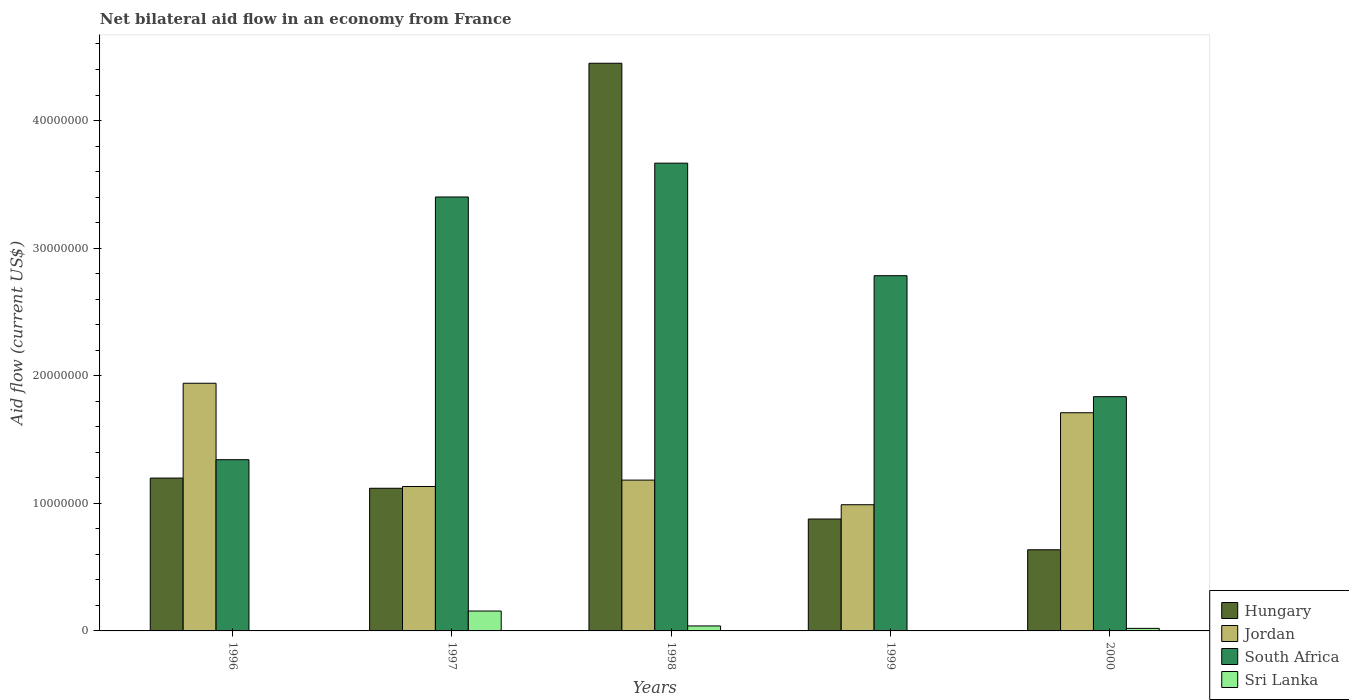How many groups of bars are there?
Your response must be concise. 5. Are the number of bars on each tick of the X-axis equal?
Your answer should be very brief. No. How many bars are there on the 3rd tick from the right?
Give a very brief answer. 4. What is the label of the 4th group of bars from the left?
Ensure brevity in your answer.  1999. In how many cases, is the number of bars for a given year not equal to the number of legend labels?
Provide a short and direct response. 2. What is the net bilateral aid flow in Sri Lanka in 1999?
Offer a terse response. 0. Across all years, what is the maximum net bilateral aid flow in Sri Lanka?
Provide a short and direct response. 1.56e+06. Across all years, what is the minimum net bilateral aid flow in Hungary?
Your answer should be very brief. 6.36e+06. What is the total net bilateral aid flow in Hungary in the graph?
Offer a terse response. 8.28e+07. What is the difference between the net bilateral aid flow in Jordan in 1996 and that in 1999?
Your answer should be compact. 9.52e+06. What is the difference between the net bilateral aid flow in Sri Lanka in 1997 and the net bilateral aid flow in South Africa in 1999?
Your response must be concise. -2.63e+07. What is the average net bilateral aid flow in Hungary per year?
Ensure brevity in your answer.  1.66e+07. In the year 1998, what is the difference between the net bilateral aid flow in Sri Lanka and net bilateral aid flow in Hungary?
Provide a succinct answer. -4.41e+07. What is the ratio of the net bilateral aid flow in Hungary in 1997 to that in 2000?
Keep it short and to the point. 1.76. Is the net bilateral aid flow in Sri Lanka in 1997 less than that in 2000?
Give a very brief answer. No. Is the difference between the net bilateral aid flow in Sri Lanka in 1997 and 2000 greater than the difference between the net bilateral aid flow in Hungary in 1997 and 2000?
Offer a terse response. No. What is the difference between the highest and the second highest net bilateral aid flow in Sri Lanka?
Your answer should be very brief. 1.17e+06. What is the difference between the highest and the lowest net bilateral aid flow in Hungary?
Provide a short and direct response. 3.81e+07. Is the sum of the net bilateral aid flow in Jordan in 1998 and 2000 greater than the maximum net bilateral aid flow in South Africa across all years?
Your response must be concise. No. Is it the case that in every year, the sum of the net bilateral aid flow in Sri Lanka and net bilateral aid flow in South Africa is greater than the net bilateral aid flow in Jordan?
Make the answer very short. No. How many bars are there?
Your answer should be compact. 18. Where does the legend appear in the graph?
Your response must be concise. Bottom right. How many legend labels are there?
Provide a succinct answer. 4. What is the title of the graph?
Offer a very short reply. Net bilateral aid flow in an economy from France. Does "Qatar" appear as one of the legend labels in the graph?
Provide a succinct answer. No. What is the label or title of the Y-axis?
Ensure brevity in your answer.  Aid flow (current US$). What is the Aid flow (current US$) of Hungary in 1996?
Keep it short and to the point. 1.20e+07. What is the Aid flow (current US$) of Jordan in 1996?
Provide a succinct answer. 1.94e+07. What is the Aid flow (current US$) of South Africa in 1996?
Ensure brevity in your answer.  1.34e+07. What is the Aid flow (current US$) in Hungary in 1997?
Your answer should be very brief. 1.12e+07. What is the Aid flow (current US$) of Jordan in 1997?
Keep it short and to the point. 1.13e+07. What is the Aid flow (current US$) in South Africa in 1997?
Offer a very short reply. 3.40e+07. What is the Aid flow (current US$) of Sri Lanka in 1997?
Ensure brevity in your answer.  1.56e+06. What is the Aid flow (current US$) of Hungary in 1998?
Give a very brief answer. 4.45e+07. What is the Aid flow (current US$) in Jordan in 1998?
Give a very brief answer. 1.18e+07. What is the Aid flow (current US$) in South Africa in 1998?
Make the answer very short. 3.67e+07. What is the Aid flow (current US$) of Sri Lanka in 1998?
Your answer should be compact. 3.90e+05. What is the Aid flow (current US$) in Hungary in 1999?
Your response must be concise. 8.77e+06. What is the Aid flow (current US$) of Jordan in 1999?
Your answer should be compact. 9.89e+06. What is the Aid flow (current US$) in South Africa in 1999?
Provide a short and direct response. 2.78e+07. What is the Aid flow (current US$) of Hungary in 2000?
Your answer should be very brief. 6.36e+06. What is the Aid flow (current US$) in Jordan in 2000?
Make the answer very short. 1.71e+07. What is the Aid flow (current US$) of South Africa in 2000?
Provide a short and direct response. 1.84e+07. Across all years, what is the maximum Aid flow (current US$) of Hungary?
Your answer should be compact. 4.45e+07. Across all years, what is the maximum Aid flow (current US$) in Jordan?
Provide a succinct answer. 1.94e+07. Across all years, what is the maximum Aid flow (current US$) in South Africa?
Your answer should be very brief. 3.67e+07. Across all years, what is the maximum Aid flow (current US$) in Sri Lanka?
Your response must be concise. 1.56e+06. Across all years, what is the minimum Aid flow (current US$) in Hungary?
Keep it short and to the point. 6.36e+06. Across all years, what is the minimum Aid flow (current US$) in Jordan?
Provide a succinct answer. 9.89e+06. Across all years, what is the minimum Aid flow (current US$) of South Africa?
Ensure brevity in your answer.  1.34e+07. Across all years, what is the minimum Aid flow (current US$) of Sri Lanka?
Provide a succinct answer. 0. What is the total Aid flow (current US$) in Hungary in the graph?
Keep it short and to the point. 8.28e+07. What is the total Aid flow (current US$) of Jordan in the graph?
Ensure brevity in your answer.  6.95e+07. What is the total Aid flow (current US$) in South Africa in the graph?
Keep it short and to the point. 1.30e+08. What is the total Aid flow (current US$) in Sri Lanka in the graph?
Offer a very short reply. 2.15e+06. What is the difference between the Aid flow (current US$) in Jordan in 1996 and that in 1997?
Give a very brief answer. 8.09e+06. What is the difference between the Aid flow (current US$) of South Africa in 1996 and that in 1997?
Ensure brevity in your answer.  -2.06e+07. What is the difference between the Aid flow (current US$) in Hungary in 1996 and that in 1998?
Offer a terse response. -3.25e+07. What is the difference between the Aid flow (current US$) in Jordan in 1996 and that in 1998?
Provide a short and direct response. 7.59e+06. What is the difference between the Aid flow (current US$) of South Africa in 1996 and that in 1998?
Ensure brevity in your answer.  -2.32e+07. What is the difference between the Aid flow (current US$) in Hungary in 1996 and that in 1999?
Ensure brevity in your answer.  3.21e+06. What is the difference between the Aid flow (current US$) in Jordan in 1996 and that in 1999?
Your answer should be very brief. 9.52e+06. What is the difference between the Aid flow (current US$) of South Africa in 1996 and that in 1999?
Your answer should be very brief. -1.44e+07. What is the difference between the Aid flow (current US$) in Hungary in 1996 and that in 2000?
Ensure brevity in your answer.  5.62e+06. What is the difference between the Aid flow (current US$) of Jordan in 1996 and that in 2000?
Your answer should be very brief. 2.31e+06. What is the difference between the Aid flow (current US$) of South Africa in 1996 and that in 2000?
Make the answer very short. -4.94e+06. What is the difference between the Aid flow (current US$) of Hungary in 1997 and that in 1998?
Give a very brief answer. -3.33e+07. What is the difference between the Aid flow (current US$) in Jordan in 1997 and that in 1998?
Your response must be concise. -5.00e+05. What is the difference between the Aid flow (current US$) in South Africa in 1997 and that in 1998?
Ensure brevity in your answer.  -2.65e+06. What is the difference between the Aid flow (current US$) of Sri Lanka in 1997 and that in 1998?
Your response must be concise. 1.17e+06. What is the difference between the Aid flow (current US$) of Hungary in 1997 and that in 1999?
Your answer should be compact. 2.41e+06. What is the difference between the Aid flow (current US$) in Jordan in 1997 and that in 1999?
Give a very brief answer. 1.43e+06. What is the difference between the Aid flow (current US$) in South Africa in 1997 and that in 1999?
Keep it short and to the point. 6.17e+06. What is the difference between the Aid flow (current US$) in Hungary in 1997 and that in 2000?
Give a very brief answer. 4.82e+06. What is the difference between the Aid flow (current US$) of Jordan in 1997 and that in 2000?
Provide a succinct answer. -5.78e+06. What is the difference between the Aid flow (current US$) of South Africa in 1997 and that in 2000?
Offer a terse response. 1.56e+07. What is the difference between the Aid flow (current US$) of Sri Lanka in 1997 and that in 2000?
Offer a very short reply. 1.36e+06. What is the difference between the Aid flow (current US$) in Hungary in 1998 and that in 1999?
Give a very brief answer. 3.57e+07. What is the difference between the Aid flow (current US$) in Jordan in 1998 and that in 1999?
Your answer should be compact. 1.93e+06. What is the difference between the Aid flow (current US$) of South Africa in 1998 and that in 1999?
Provide a short and direct response. 8.82e+06. What is the difference between the Aid flow (current US$) in Hungary in 1998 and that in 2000?
Your response must be concise. 3.81e+07. What is the difference between the Aid flow (current US$) in Jordan in 1998 and that in 2000?
Provide a succinct answer. -5.28e+06. What is the difference between the Aid flow (current US$) in South Africa in 1998 and that in 2000?
Offer a terse response. 1.83e+07. What is the difference between the Aid flow (current US$) of Hungary in 1999 and that in 2000?
Ensure brevity in your answer.  2.41e+06. What is the difference between the Aid flow (current US$) of Jordan in 1999 and that in 2000?
Keep it short and to the point. -7.21e+06. What is the difference between the Aid flow (current US$) of South Africa in 1999 and that in 2000?
Your answer should be very brief. 9.48e+06. What is the difference between the Aid flow (current US$) in Hungary in 1996 and the Aid flow (current US$) in Jordan in 1997?
Make the answer very short. 6.60e+05. What is the difference between the Aid flow (current US$) of Hungary in 1996 and the Aid flow (current US$) of South Africa in 1997?
Your answer should be compact. -2.20e+07. What is the difference between the Aid flow (current US$) of Hungary in 1996 and the Aid flow (current US$) of Sri Lanka in 1997?
Offer a terse response. 1.04e+07. What is the difference between the Aid flow (current US$) of Jordan in 1996 and the Aid flow (current US$) of South Africa in 1997?
Provide a short and direct response. -1.46e+07. What is the difference between the Aid flow (current US$) in Jordan in 1996 and the Aid flow (current US$) in Sri Lanka in 1997?
Keep it short and to the point. 1.78e+07. What is the difference between the Aid flow (current US$) of South Africa in 1996 and the Aid flow (current US$) of Sri Lanka in 1997?
Offer a terse response. 1.19e+07. What is the difference between the Aid flow (current US$) of Hungary in 1996 and the Aid flow (current US$) of South Africa in 1998?
Your answer should be very brief. -2.47e+07. What is the difference between the Aid flow (current US$) in Hungary in 1996 and the Aid flow (current US$) in Sri Lanka in 1998?
Your answer should be very brief. 1.16e+07. What is the difference between the Aid flow (current US$) of Jordan in 1996 and the Aid flow (current US$) of South Africa in 1998?
Your answer should be very brief. -1.72e+07. What is the difference between the Aid flow (current US$) of Jordan in 1996 and the Aid flow (current US$) of Sri Lanka in 1998?
Your answer should be compact. 1.90e+07. What is the difference between the Aid flow (current US$) in South Africa in 1996 and the Aid flow (current US$) in Sri Lanka in 1998?
Provide a short and direct response. 1.30e+07. What is the difference between the Aid flow (current US$) in Hungary in 1996 and the Aid flow (current US$) in Jordan in 1999?
Make the answer very short. 2.09e+06. What is the difference between the Aid flow (current US$) of Hungary in 1996 and the Aid flow (current US$) of South Africa in 1999?
Offer a terse response. -1.59e+07. What is the difference between the Aid flow (current US$) of Jordan in 1996 and the Aid flow (current US$) of South Africa in 1999?
Make the answer very short. -8.43e+06. What is the difference between the Aid flow (current US$) in Hungary in 1996 and the Aid flow (current US$) in Jordan in 2000?
Keep it short and to the point. -5.12e+06. What is the difference between the Aid flow (current US$) of Hungary in 1996 and the Aid flow (current US$) of South Africa in 2000?
Keep it short and to the point. -6.38e+06. What is the difference between the Aid flow (current US$) in Hungary in 1996 and the Aid flow (current US$) in Sri Lanka in 2000?
Give a very brief answer. 1.18e+07. What is the difference between the Aid flow (current US$) of Jordan in 1996 and the Aid flow (current US$) of South Africa in 2000?
Make the answer very short. 1.05e+06. What is the difference between the Aid flow (current US$) of Jordan in 1996 and the Aid flow (current US$) of Sri Lanka in 2000?
Ensure brevity in your answer.  1.92e+07. What is the difference between the Aid flow (current US$) of South Africa in 1996 and the Aid flow (current US$) of Sri Lanka in 2000?
Offer a terse response. 1.32e+07. What is the difference between the Aid flow (current US$) of Hungary in 1997 and the Aid flow (current US$) of Jordan in 1998?
Your response must be concise. -6.40e+05. What is the difference between the Aid flow (current US$) of Hungary in 1997 and the Aid flow (current US$) of South Africa in 1998?
Ensure brevity in your answer.  -2.55e+07. What is the difference between the Aid flow (current US$) of Hungary in 1997 and the Aid flow (current US$) of Sri Lanka in 1998?
Your answer should be compact. 1.08e+07. What is the difference between the Aid flow (current US$) in Jordan in 1997 and the Aid flow (current US$) in South Africa in 1998?
Your answer should be compact. -2.53e+07. What is the difference between the Aid flow (current US$) in Jordan in 1997 and the Aid flow (current US$) in Sri Lanka in 1998?
Your answer should be very brief. 1.09e+07. What is the difference between the Aid flow (current US$) in South Africa in 1997 and the Aid flow (current US$) in Sri Lanka in 1998?
Offer a terse response. 3.36e+07. What is the difference between the Aid flow (current US$) of Hungary in 1997 and the Aid flow (current US$) of Jordan in 1999?
Ensure brevity in your answer.  1.29e+06. What is the difference between the Aid flow (current US$) of Hungary in 1997 and the Aid flow (current US$) of South Africa in 1999?
Your response must be concise. -1.67e+07. What is the difference between the Aid flow (current US$) in Jordan in 1997 and the Aid flow (current US$) in South Africa in 1999?
Give a very brief answer. -1.65e+07. What is the difference between the Aid flow (current US$) in Hungary in 1997 and the Aid flow (current US$) in Jordan in 2000?
Give a very brief answer. -5.92e+06. What is the difference between the Aid flow (current US$) of Hungary in 1997 and the Aid flow (current US$) of South Africa in 2000?
Provide a succinct answer. -7.18e+06. What is the difference between the Aid flow (current US$) of Hungary in 1997 and the Aid flow (current US$) of Sri Lanka in 2000?
Give a very brief answer. 1.10e+07. What is the difference between the Aid flow (current US$) of Jordan in 1997 and the Aid flow (current US$) of South Africa in 2000?
Give a very brief answer. -7.04e+06. What is the difference between the Aid flow (current US$) of Jordan in 1997 and the Aid flow (current US$) of Sri Lanka in 2000?
Your answer should be very brief. 1.11e+07. What is the difference between the Aid flow (current US$) in South Africa in 1997 and the Aid flow (current US$) in Sri Lanka in 2000?
Offer a terse response. 3.38e+07. What is the difference between the Aid flow (current US$) in Hungary in 1998 and the Aid flow (current US$) in Jordan in 1999?
Your response must be concise. 3.46e+07. What is the difference between the Aid flow (current US$) of Hungary in 1998 and the Aid flow (current US$) of South Africa in 1999?
Offer a very short reply. 1.66e+07. What is the difference between the Aid flow (current US$) of Jordan in 1998 and the Aid flow (current US$) of South Africa in 1999?
Offer a terse response. -1.60e+07. What is the difference between the Aid flow (current US$) in Hungary in 1998 and the Aid flow (current US$) in Jordan in 2000?
Keep it short and to the point. 2.74e+07. What is the difference between the Aid flow (current US$) in Hungary in 1998 and the Aid flow (current US$) in South Africa in 2000?
Provide a short and direct response. 2.61e+07. What is the difference between the Aid flow (current US$) in Hungary in 1998 and the Aid flow (current US$) in Sri Lanka in 2000?
Your response must be concise. 4.43e+07. What is the difference between the Aid flow (current US$) in Jordan in 1998 and the Aid flow (current US$) in South Africa in 2000?
Your answer should be very brief. -6.54e+06. What is the difference between the Aid flow (current US$) of Jordan in 1998 and the Aid flow (current US$) of Sri Lanka in 2000?
Your response must be concise. 1.16e+07. What is the difference between the Aid flow (current US$) in South Africa in 1998 and the Aid flow (current US$) in Sri Lanka in 2000?
Offer a terse response. 3.65e+07. What is the difference between the Aid flow (current US$) in Hungary in 1999 and the Aid flow (current US$) in Jordan in 2000?
Keep it short and to the point. -8.33e+06. What is the difference between the Aid flow (current US$) of Hungary in 1999 and the Aid flow (current US$) of South Africa in 2000?
Provide a short and direct response. -9.59e+06. What is the difference between the Aid flow (current US$) of Hungary in 1999 and the Aid flow (current US$) of Sri Lanka in 2000?
Offer a terse response. 8.57e+06. What is the difference between the Aid flow (current US$) in Jordan in 1999 and the Aid flow (current US$) in South Africa in 2000?
Give a very brief answer. -8.47e+06. What is the difference between the Aid flow (current US$) of Jordan in 1999 and the Aid flow (current US$) of Sri Lanka in 2000?
Provide a short and direct response. 9.69e+06. What is the difference between the Aid flow (current US$) in South Africa in 1999 and the Aid flow (current US$) in Sri Lanka in 2000?
Your answer should be compact. 2.76e+07. What is the average Aid flow (current US$) of Hungary per year?
Provide a short and direct response. 1.66e+07. What is the average Aid flow (current US$) in Jordan per year?
Your answer should be compact. 1.39e+07. What is the average Aid flow (current US$) in South Africa per year?
Offer a very short reply. 2.61e+07. What is the average Aid flow (current US$) of Sri Lanka per year?
Keep it short and to the point. 4.30e+05. In the year 1996, what is the difference between the Aid flow (current US$) in Hungary and Aid flow (current US$) in Jordan?
Offer a terse response. -7.43e+06. In the year 1996, what is the difference between the Aid flow (current US$) of Hungary and Aid flow (current US$) of South Africa?
Give a very brief answer. -1.44e+06. In the year 1996, what is the difference between the Aid flow (current US$) in Jordan and Aid flow (current US$) in South Africa?
Ensure brevity in your answer.  5.99e+06. In the year 1997, what is the difference between the Aid flow (current US$) of Hungary and Aid flow (current US$) of Jordan?
Provide a succinct answer. -1.40e+05. In the year 1997, what is the difference between the Aid flow (current US$) in Hungary and Aid flow (current US$) in South Africa?
Your answer should be compact. -2.28e+07. In the year 1997, what is the difference between the Aid flow (current US$) of Hungary and Aid flow (current US$) of Sri Lanka?
Ensure brevity in your answer.  9.62e+06. In the year 1997, what is the difference between the Aid flow (current US$) of Jordan and Aid flow (current US$) of South Africa?
Your answer should be compact. -2.27e+07. In the year 1997, what is the difference between the Aid flow (current US$) of Jordan and Aid flow (current US$) of Sri Lanka?
Your response must be concise. 9.76e+06. In the year 1997, what is the difference between the Aid flow (current US$) in South Africa and Aid flow (current US$) in Sri Lanka?
Make the answer very short. 3.24e+07. In the year 1998, what is the difference between the Aid flow (current US$) of Hungary and Aid flow (current US$) of Jordan?
Make the answer very short. 3.27e+07. In the year 1998, what is the difference between the Aid flow (current US$) in Hungary and Aid flow (current US$) in South Africa?
Your response must be concise. 7.83e+06. In the year 1998, what is the difference between the Aid flow (current US$) of Hungary and Aid flow (current US$) of Sri Lanka?
Your answer should be very brief. 4.41e+07. In the year 1998, what is the difference between the Aid flow (current US$) in Jordan and Aid flow (current US$) in South Africa?
Your answer should be compact. -2.48e+07. In the year 1998, what is the difference between the Aid flow (current US$) in Jordan and Aid flow (current US$) in Sri Lanka?
Your response must be concise. 1.14e+07. In the year 1998, what is the difference between the Aid flow (current US$) in South Africa and Aid flow (current US$) in Sri Lanka?
Your answer should be very brief. 3.63e+07. In the year 1999, what is the difference between the Aid flow (current US$) of Hungary and Aid flow (current US$) of Jordan?
Keep it short and to the point. -1.12e+06. In the year 1999, what is the difference between the Aid flow (current US$) in Hungary and Aid flow (current US$) in South Africa?
Your answer should be compact. -1.91e+07. In the year 1999, what is the difference between the Aid flow (current US$) of Jordan and Aid flow (current US$) of South Africa?
Provide a succinct answer. -1.80e+07. In the year 2000, what is the difference between the Aid flow (current US$) in Hungary and Aid flow (current US$) in Jordan?
Your response must be concise. -1.07e+07. In the year 2000, what is the difference between the Aid flow (current US$) in Hungary and Aid flow (current US$) in South Africa?
Your answer should be very brief. -1.20e+07. In the year 2000, what is the difference between the Aid flow (current US$) in Hungary and Aid flow (current US$) in Sri Lanka?
Ensure brevity in your answer.  6.16e+06. In the year 2000, what is the difference between the Aid flow (current US$) of Jordan and Aid flow (current US$) of South Africa?
Ensure brevity in your answer.  -1.26e+06. In the year 2000, what is the difference between the Aid flow (current US$) of Jordan and Aid flow (current US$) of Sri Lanka?
Keep it short and to the point. 1.69e+07. In the year 2000, what is the difference between the Aid flow (current US$) in South Africa and Aid flow (current US$) in Sri Lanka?
Keep it short and to the point. 1.82e+07. What is the ratio of the Aid flow (current US$) in Hungary in 1996 to that in 1997?
Make the answer very short. 1.07. What is the ratio of the Aid flow (current US$) in Jordan in 1996 to that in 1997?
Your answer should be compact. 1.71. What is the ratio of the Aid flow (current US$) in South Africa in 1996 to that in 1997?
Ensure brevity in your answer.  0.39. What is the ratio of the Aid flow (current US$) in Hungary in 1996 to that in 1998?
Provide a short and direct response. 0.27. What is the ratio of the Aid flow (current US$) of Jordan in 1996 to that in 1998?
Keep it short and to the point. 1.64. What is the ratio of the Aid flow (current US$) of South Africa in 1996 to that in 1998?
Give a very brief answer. 0.37. What is the ratio of the Aid flow (current US$) in Hungary in 1996 to that in 1999?
Ensure brevity in your answer.  1.37. What is the ratio of the Aid flow (current US$) in Jordan in 1996 to that in 1999?
Ensure brevity in your answer.  1.96. What is the ratio of the Aid flow (current US$) of South Africa in 1996 to that in 1999?
Offer a terse response. 0.48. What is the ratio of the Aid flow (current US$) of Hungary in 1996 to that in 2000?
Make the answer very short. 1.88. What is the ratio of the Aid flow (current US$) of Jordan in 1996 to that in 2000?
Your answer should be very brief. 1.14. What is the ratio of the Aid flow (current US$) of South Africa in 1996 to that in 2000?
Provide a short and direct response. 0.73. What is the ratio of the Aid flow (current US$) in Hungary in 1997 to that in 1998?
Your answer should be very brief. 0.25. What is the ratio of the Aid flow (current US$) in Jordan in 1997 to that in 1998?
Make the answer very short. 0.96. What is the ratio of the Aid flow (current US$) in South Africa in 1997 to that in 1998?
Your answer should be compact. 0.93. What is the ratio of the Aid flow (current US$) of Hungary in 1997 to that in 1999?
Provide a succinct answer. 1.27. What is the ratio of the Aid flow (current US$) in Jordan in 1997 to that in 1999?
Offer a very short reply. 1.14. What is the ratio of the Aid flow (current US$) in South Africa in 1997 to that in 1999?
Your answer should be very brief. 1.22. What is the ratio of the Aid flow (current US$) in Hungary in 1997 to that in 2000?
Provide a short and direct response. 1.76. What is the ratio of the Aid flow (current US$) in Jordan in 1997 to that in 2000?
Keep it short and to the point. 0.66. What is the ratio of the Aid flow (current US$) of South Africa in 1997 to that in 2000?
Offer a terse response. 1.85. What is the ratio of the Aid flow (current US$) in Hungary in 1998 to that in 1999?
Provide a short and direct response. 5.07. What is the ratio of the Aid flow (current US$) of Jordan in 1998 to that in 1999?
Offer a very short reply. 1.2. What is the ratio of the Aid flow (current US$) of South Africa in 1998 to that in 1999?
Your answer should be very brief. 1.32. What is the ratio of the Aid flow (current US$) in Hungary in 1998 to that in 2000?
Offer a very short reply. 7. What is the ratio of the Aid flow (current US$) in Jordan in 1998 to that in 2000?
Keep it short and to the point. 0.69. What is the ratio of the Aid flow (current US$) in South Africa in 1998 to that in 2000?
Offer a very short reply. 2. What is the ratio of the Aid flow (current US$) of Sri Lanka in 1998 to that in 2000?
Offer a very short reply. 1.95. What is the ratio of the Aid flow (current US$) of Hungary in 1999 to that in 2000?
Ensure brevity in your answer.  1.38. What is the ratio of the Aid flow (current US$) in Jordan in 1999 to that in 2000?
Your answer should be very brief. 0.58. What is the ratio of the Aid flow (current US$) in South Africa in 1999 to that in 2000?
Provide a succinct answer. 1.52. What is the difference between the highest and the second highest Aid flow (current US$) of Hungary?
Make the answer very short. 3.25e+07. What is the difference between the highest and the second highest Aid flow (current US$) in Jordan?
Your answer should be compact. 2.31e+06. What is the difference between the highest and the second highest Aid flow (current US$) of South Africa?
Your answer should be very brief. 2.65e+06. What is the difference between the highest and the second highest Aid flow (current US$) in Sri Lanka?
Provide a succinct answer. 1.17e+06. What is the difference between the highest and the lowest Aid flow (current US$) in Hungary?
Provide a short and direct response. 3.81e+07. What is the difference between the highest and the lowest Aid flow (current US$) in Jordan?
Provide a succinct answer. 9.52e+06. What is the difference between the highest and the lowest Aid flow (current US$) in South Africa?
Keep it short and to the point. 2.32e+07. What is the difference between the highest and the lowest Aid flow (current US$) of Sri Lanka?
Ensure brevity in your answer.  1.56e+06. 